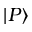<formula> <loc_0><loc_0><loc_500><loc_500>| P \rangle</formula> 